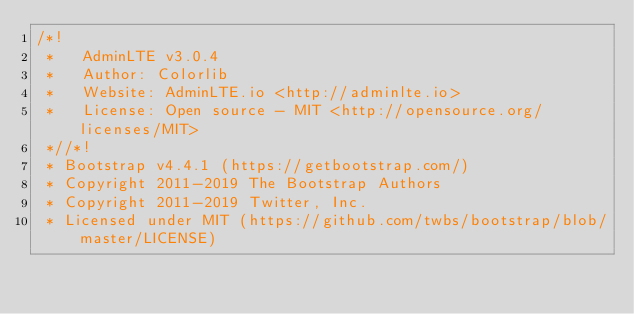Convert code to text. <code><loc_0><loc_0><loc_500><loc_500><_CSS_>/*!
 *   AdminLTE v3.0.4
 *   Author: Colorlib
 *   Website: AdminLTE.io <http://adminlte.io>
 *   License: Open source - MIT <http://opensource.org/licenses/MIT>
 *//*!
 * Bootstrap v4.4.1 (https://getbootstrap.com/)
 * Copyright 2011-2019 The Bootstrap Authors
 * Copyright 2011-2019 Twitter, Inc.
 * Licensed under MIT (https://github.com/twbs/bootstrap/blob/master/LICENSE)</code> 